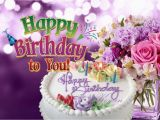Don't forget these rules:
 
1. **Be Direct and Concise**: Provide straightforward descriptions without adding interpretative or speculative elements.
2. **Use Segmented Details**: Break down details about different elements of an image into distinct sentences, focusing on one aspect at a time.
3. **Maintain a Descriptive Focus**: Prioritize purely visible elements of the image, avoiding conclusions or inferences.
4. **Follow a Logical Structure**: Begin with the central figure or subject and expand outward, detailing its appearance before addressing the surrounding setting.
5. **Avoid Juxtaposition**: Do not use comparison or contrast language; keep the description purely factual.
6. **Incorporate Specificity**: Mention age, gender, race, and specific brands or notable features when present, and clearly identify the medium if it's discernible. 
 
When writing descriptions, prioritize clarity and direct observation over embellishment or interpretation.
 
Write a detailed description of this image, do not forget about the texts on it if they exist. Also, do not forget to mention the type / style of the image. No bullet points. The image is a colorful graphic with a celebratory theme, likely designed as a birthday greeting. In the foreground, there is a round, white-frosted birthday cake with lit candles and the words "Happy Birthday" written in decorative icing. To the right of the cake, a bouquet of fresh flowers with various shades of purple, pink, and white blooms is visible. The background is a gradient of purple hues, and atop the image, the text "Happy Birthday to You" is displayed in a playful, multicolored font with a slight three-dimensional effect. The overall style of the image is festive and vibrant, with a focus on conveying birthday wishes. 